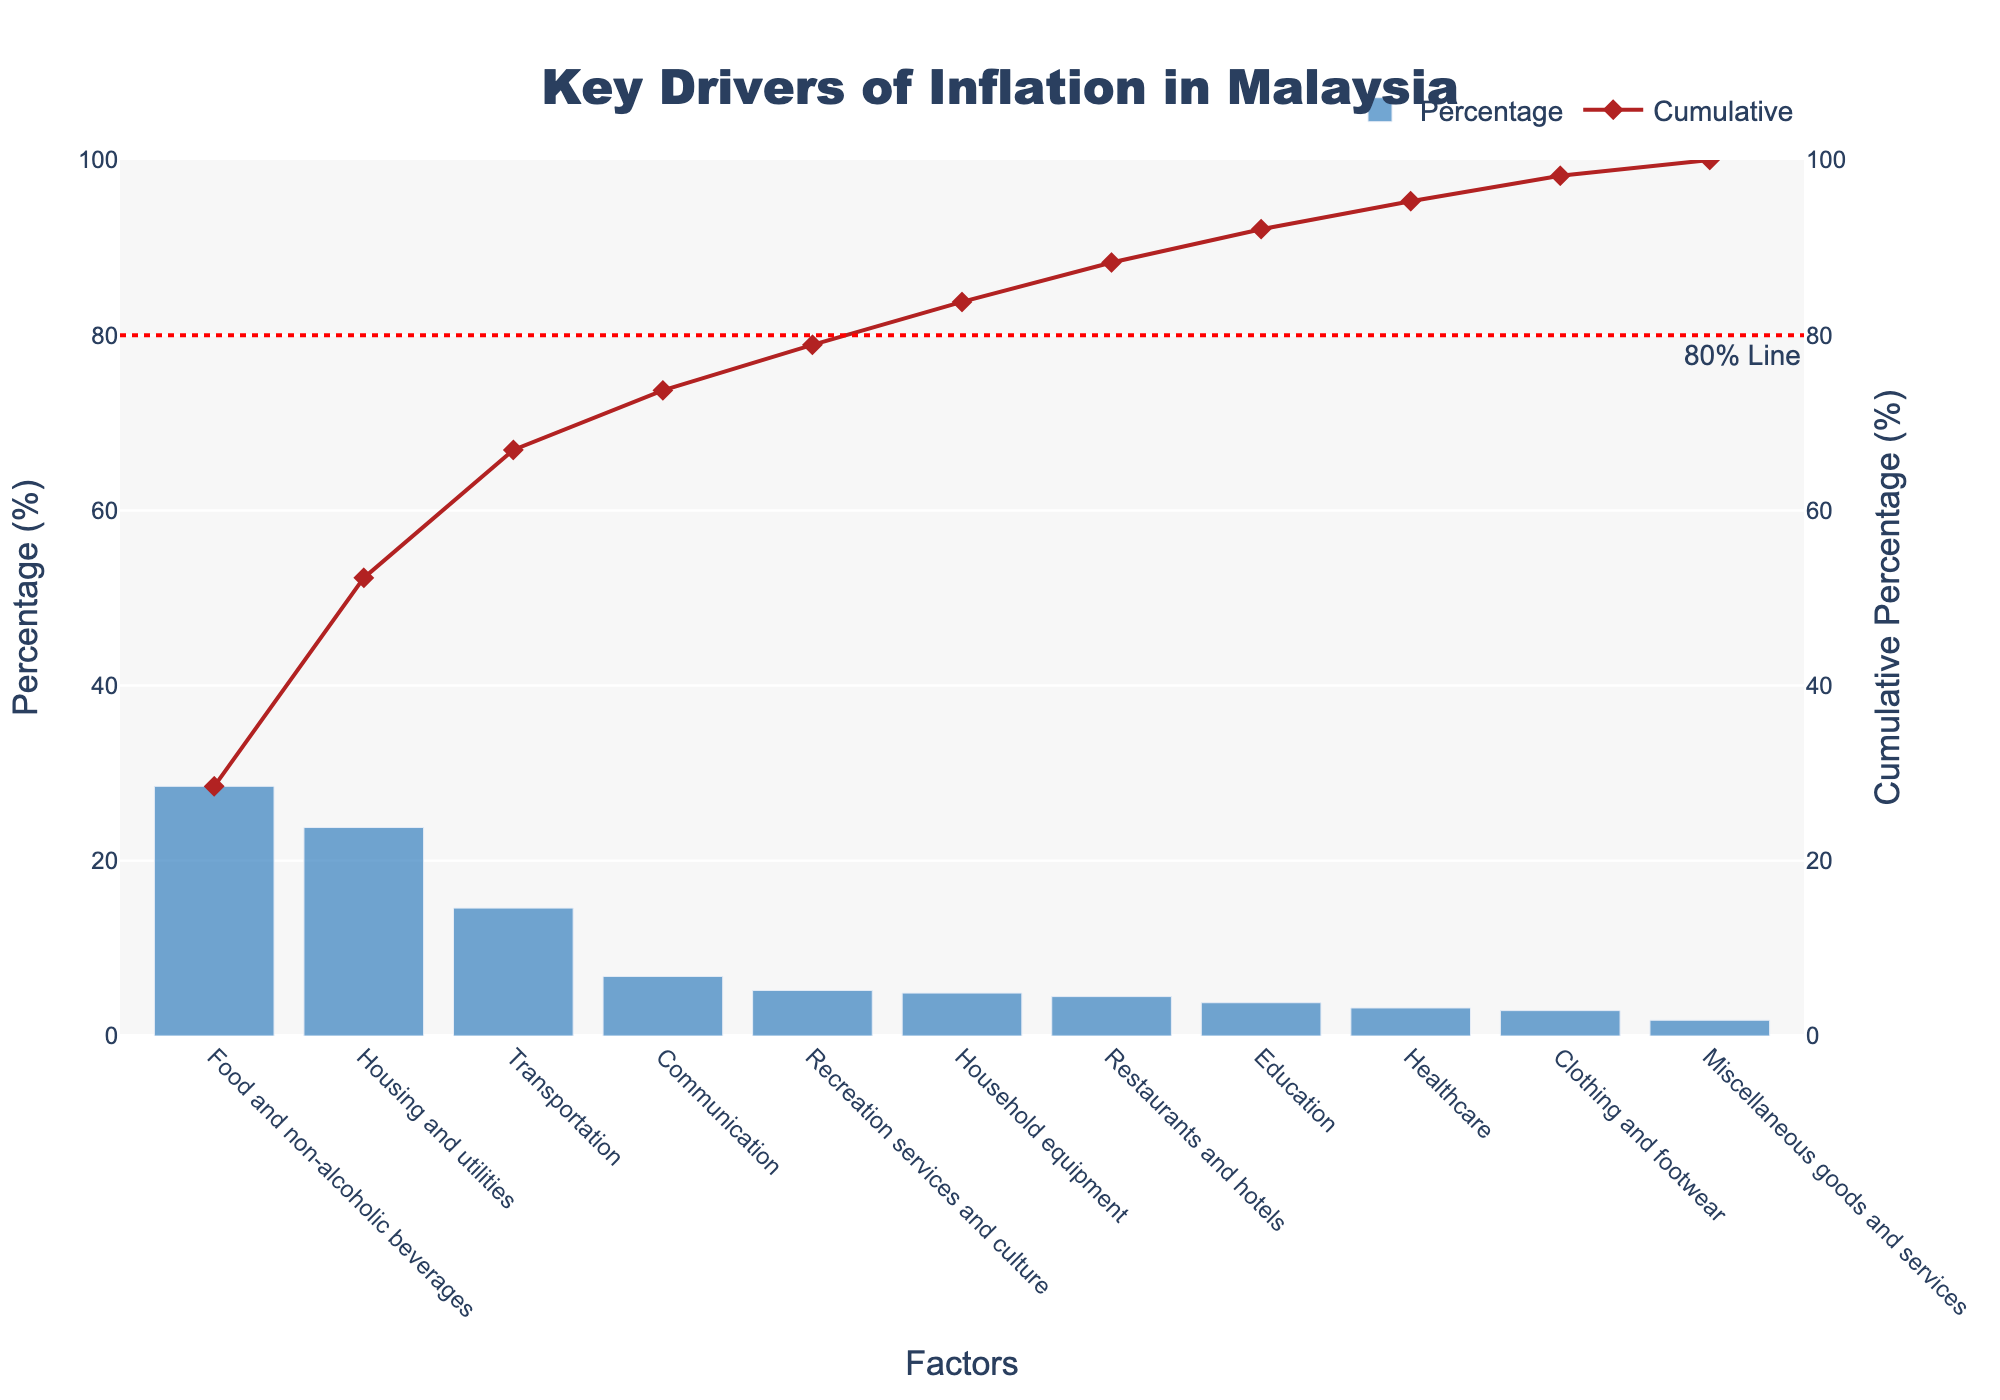What's the title of the figure? The title is at the top center of the figure, indicating what the chart is about.
Answer: Key Drivers of Inflation in Malaysia Which factor contributes the most to inflation in Malaysia? The factor with the highest bar represents the largest contributor to inflation.
Answer: Food and non-alcoholic beverages How much does transportation contribute to inflation? The percentage contribution of transportation is shown by the bar labeled 'Transportation'.
Answer: 14.6% Which three factors contribute the least to inflation in Malaysia? The three shortest bars in the chart represent the least contributors.
Answer: Education, Healthcare, and Clothing and footwear What's the cumulative percentage after including the contribution from transportation? Find the cumulative percentage at the point where transportation is included in the line graph.
Answer: 66.9% What is the cumulative percentage just before crossing the 80% reference line? Identify the cumulative percentage value right before it exceeds 80% on the line graph.
Answer: 73.9% How does the contribution of housing and utilities compare to that of household equipment? Compare the heights of the bars labeled 'Housing and utilities' and 'Household equipment'.
Answer: Housing and utilities is higher If you combine the contributions of healthcare and communication, what is the total percentage? Add the percentages of healthcare and communication.
Answer: 10% Which factors together account for over 50% of the total inflation? The cumulative percentage line helps identify the factors whose combined percentage exceeds 50%.
Answer: Food and non-alcoholic beverages, Housing and utilities, and Transportation What is the cumulative percentage after including 'Recreation services and culture'? Locate the cumulative value at the point of including 'Recreation services and culture'.
Answer: 79.9% 